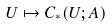Convert formula to latex. <formula><loc_0><loc_0><loc_500><loc_500>U \mapsto C _ { * } ( U ; A )</formula> 